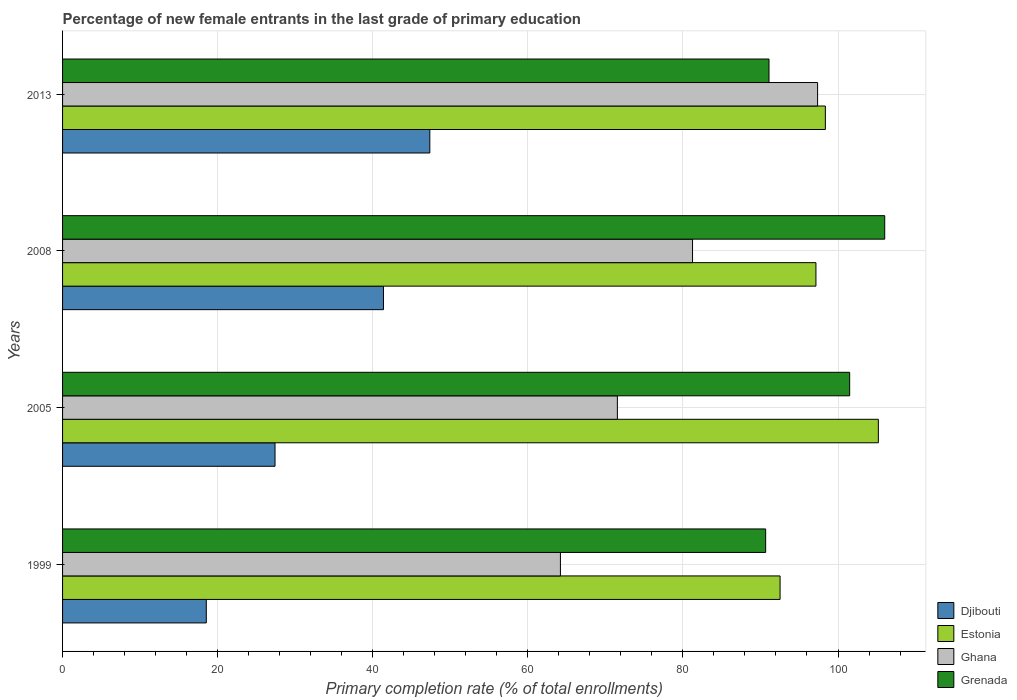What is the label of the 4th group of bars from the top?
Your answer should be very brief. 1999. What is the percentage of new female entrants in Ghana in 2013?
Provide a succinct answer. 97.37. Across all years, what is the maximum percentage of new female entrants in Estonia?
Give a very brief answer. 105.2. Across all years, what is the minimum percentage of new female entrants in Ghana?
Your response must be concise. 64.2. In which year was the percentage of new female entrants in Ghana maximum?
Ensure brevity in your answer.  2013. What is the total percentage of new female entrants in Grenada in the graph?
Your answer should be very brief. 389.3. What is the difference between the percentage of new female entrants in Djibouti in 1999 and that in 2005?
Your response must be concise. -8.86. What is the difference between the percentage of new female entrants in Grenada in 2005 and the percentage of new female entrants in Djibouti in 1999?
Provide a succinct answer. 82.97. What is the average percentage of new female entrants in Djibouti per year?
Your answer should be compact. 33.67. In the year 2008, what is the difference between the percentage of new female entrants in Ghana and percentage of new female entrants in Grenada?
Keep it short and to the point. -24.78. What is the ratio of the percentage of new female entrants in Grenada in 1999 to that in 2013?
Provide a short and direct response. 1. Is the difference between the percentage of new female entrants in Ghana in 1999 and 2013 greater than the difference between the percentage of new female entrants in Grenada in 1999 and 2013?
Your answer should be very brief. No. What is the difference between the highest and the second highest percentage of new female entrants in Grenada?
Your response must be concise. 4.52. What is the difference between the highest and the lowest percentage of new female entrants in Djibouti?
Offer a very short reply. 28.83. In how many years, is the percentage of new female entrants in Ghana greater than the average percentage of new female entrants in Ghana taken over all years?
Your answer should be very brief. 2. What does the 4th bar from the top in 2008 represents?
Provide a succinct answer. Djibouti. Is it the case that in every year, the sum of the percentage of new female entrants in Estonia and percentage of new female entrants in Ghana is greater than the percentage of new female entrants in Djibouti?
Make the answer very short. Yes. What is the difference between two consecutive major ticks on the X-axis?
Provide a short and direct response. 20. Are the values on the major ticks of X-axis written in scientific E-notation?
Keep it short and to the point. No. Where does the legend appear in the graph?
Offer a very short reply. Bottom right. How many legend labels are there?
Give a very brief answer. 4. How are the legend labels stacked?
Provide a succinct answer. Vertical. What is the title of the graph?
Give a very brief answer. Percentage of new female entrants in the last grade of primary education. What is the label or title of the X-axis?
Provide a short and direct response. Primary completion rate (% of total enrollments). What is the Primary completion rate (% of total enrollments) in Djibouti in 1999?
Offer a terse response. 18.54. What is the Primary completion rate (% of total enrollments) of Estonia in 1999?
Provide a short and direct response. 92.53. What is the Primary completion rate (% of total enrollments) of Ghana in 1999?
Give a very brief answer. 64.2. What is the Primary completion rate (% of total enrollments) of Grenada in 1999?
Give a very brief answer. 90.67. What is the Primary completion rate (% of total enrollments) in Djibouti in 2005?
Your response must be concise. 27.4. What is the Primary completion rate (% of total enrollments) in Estonia in 2005?
Offer a very short reply. 105.2. What is the Primary completion rate (% of total enrollments) of Ghana in 2005?
Provide a short and direct response. 71.55. What is the Primary completion rate (% of total enrollments) in Grenada in 2005?
Ensure brevity in your answer.  101.5. What is the Primary completion rate (% of total enrollments) in Djibouti in 2008?
Offer a very short reply. 41.38. What is the Primary completion rate (% of total enrollments) of Estonia in 2008?
Provide a succinct answer. 97.15. What is the Primary completion rate (% of total enrollments) in Ghana in 2008?
Your response must be concise. 81.24. What is the Primary completion rate (% of total enrollments) in Grenada in 2008?
Your answer should be compact. 106.02. What is the Primary completion rate (% of total enrollments) in Djibouti in 2013?
Provide a succinct answer. 47.36. What is the Primary completion rate (% of total enrollments) in Estonia in 2013?
Provide a succinct answer. 98.37. What is the Primary completion rate (% of total enrollments) of Ghana in 2013?
Your response must be concise. 97.37. What is the Primary completion rate (% of total enrollments) of Grenada in 2013?
Make the answer very short. 91.1. Across all years, what is the maximum Primary completion rate (% of total enrollments) in Djibouti?
Your answer should be compact. 47.36. Across all years, what is the maximum Primary completion rate (% of total enrollments) of Estonia?
Keep it short and to the point. 105.2. Across all years, what is the maximum Primary completion rate (% of total enrollments) in Ghana?
Ensure brevity in your answer.  97.37. Across all years, what is the maximum Primary completion rate (% of total enrollments) of Grenada?
Give a very brief answer. 106.02. Across all years, what is the minimum Primary completion rate (% of total enrollments) of Djibouti?
Your response must be concise. 18.54. Across all years, what is the minimum Primary completion rate (% of total enrollments) in Estonia?
Provide a succinct answer. 92.53. Across all years, what is the minimum Primary completion rate (% of total enrollments) of Ghana?
Keep it short and to the point. 64.2. Across all years, what is the minimum Primary completion rate (% of total enrollments) in Grenada?
Your response must be concise. 90.67. What is the total Primary completion rate (% of total enrollments) of Djibouti in the graph?
Ensure brevity in your answer.  134.68. What is the total Primary completion rate (% of total enrollments) in Estonia in the graph?
Give a very brief answer. 393.25. What is the total Primary completion rate (% of total enrollments) of Ghana in the graph?
Offer a very short reply. 314.36. What is the total Primary completion rate (% of total enrollments) in Grenada in the graph?
Make the answer very short. 389.3. What is the difference between the Primary completion rate (% of total enrollments) in Djibouti in 1999 and that in 2005?
Give a very brief answer. -8.86. What is the difference between the Primary completion rate (% of total enrollments) of Estonia in 1999 and that in 2005?
Offer a very short reply. -12.67. What is the difference between the Primary completion rate (% of total enrollments) in Ghana in 1999 and that in 2005?
Ensure brevity in your answer.  -7.34. What is the difference between the Primary completion rate (% of total enrollments) of Grenada in 1999 and that in 2005?
Your answer should be very brief. -10.83. What is the difference between the Primary completion rate (% of total enrollments) of Djibouti in 1999 and that in 2008?
Your answer should be compact. -22.85. What is the difference between the Primary completion rate (% of total enrollments) of Estonia in 1999 and that in 2008?
Make the answer very short. -4.62. What is the difference between the Primary completion rate (% of total enrollments) of Ghana in 1999 and that in 2008?
Keep it short and to the point. -17.04. What is the difference between the Primary completion rate (% of total enrollments) in Grenada in 1999 and that in 2008?
Make the answer very short. -15.35. What is the difference between the Primary completion rate (% of total enrollments) in Djibouti in 1999 and that in 2013?
Provide a short and direct response. -28.83. What is the difference between the Primary completion rate (% of total enrollments) of Estonia in 1999 and that in 2013?
Offer a very short reply. -5.84. What is the difference between the Primary completion rate (% of total enrollments) in Ghana in 1999 and that in 2013?
Give a very brief answer. -33.16. What is the difference between the Primary completion rate (% of total enrollments) of Grenada in 1999 and that in 2013?
Make the answer very short. -0.43. What is the difference between the Primary completion rate (% of total enrollments) of Djibouti in 2005 and that in 2008?
Provide a short and direct response. -13.99. What is the difference between the Primary completion rate (% of total enrollments) in Estonia in 2005 and that in 2008?
Your answer should be compact. 8.05. What is the difference between the Primary completion rate (% of total enrollments) in Ghana in 2005 and that in 2008?
Offer a very short reply. -9.69. What is the difference between the Primary completion rate (% of total enrollments) of Grenada in 2005 and that in 2008?
Provide a short and direct response. -4.52. What is the difference between the Primary completion rate (% of total enrollments) in Djibouti in 2005 and that in 2013?
Offer a terse response. -19.96. What is the difference between the Primary completion rate (% of total enrollments) of Estonia in 2005 and that in 2013?
Give a very brief answer. 6.83. What is the difference between the Primary completion rate (% of total enrollments) of Ghana in 2005 and that in 2013?
Provide a short and direct response. -25.82. What is the difference between the Primary completion rate (% of total enrollments) in Grenada in 2005 and that in 2013?
Provide a short and direct response. 10.4. What is the difference between the Primary completion rate (% of total enrollments) of Djibouti in 2008 and that in 2013?
Provide a short and direct response. -5.98. What is the difference between the Primary completion rate (% of total enrollments) of Estonia in 2008 and that in 2013?
Provide a succinct answer. -1.22. What is the difference between the Primary completion rate (% of total enrollments) in Ghana in 2008 and that in 2013?
Ensure brevity in your answer.  -16.13. What is the difference between the Primary completion rate (% of total enrollments) of Grenada in 2008 and that in 2013?
Provide a succinct answer. 14.92. What is the difference between the Primary completion rate (% of total enrollments) in Djibouti in 1999 and the Primary completion rate (% of total enrollments) in Estonia in 2005?
Your answer should be compact. -86.67. What is the difference between the Primary completion rate (% of total enrollments) in Djibouti in 1999 and the Primary completion rate (% of total enrollments) in Ghana in 2005?
Offer a very short reply. -53.01. What is the difference between the Primary completion rate (% of total enrollments) of Djibouti in 1999 and the Primary completion rate (% of total enrollments) of Grenada in 2005?
Keep it short and to the point. -82.97. What is the difference between the Primary completion rate (% of total enrollments) of Estonia in 1999 and the Primary completion rate (% of total enrollments) of Ghana in 2005?
Give a very brief answer. 20.98. What is the difference between the Primary completion rate (% of total enrollments) of Estonia in 1999 and the Primary completion rate (% of total enrollments) of Grenada in 2005?
Your answer should be compact. -8.97. What is the difference between the Primary completion rate (% of total enrollments) of Ghana in 1999 and the Primary completion rate (% of total enrollments) of Grenada in 2005?
Make the answer very short. -37.3. What is the difference between the Primary completion rate (% of total enrollments) of Djibouti in 1999 and the Primary completion rate (% of total enrollments) of Estonia in 2008?
Keep it short and to the point. -78.62. What is the difference between the Primary completion rate (% of total enrollments) in Djibouti in 1999 and the Primary completion rate (% of total enrollments) in Ghana in 2008?
Ensure brevity in your answer.  -62.7. What is the difference between the Primary completion rate (% of total enrollments) in Djibouti in 1999 and the Primary completion rate (% of total enrollments) in Grenada in 2008?
Your answer should be very brief. -87.49. What is the difference between the Primary completion rate (% of total enrollments) in Estonia in 1999 and the Primary completion rate (% of total enrollments) in Ghana in 2008?
Give a very brief answer. 11.29. What is the difference between the Primary completion rate (% of total enrollments) in Estonia in 1999 and the Primary completion rate (% of total enrollments) in Grenada in 2008?
Offer a terse response. -13.49. What is the difference between the Primary completion rate (% of total enrollments) in Ghana in 1999 and the Primary completion rate (% of total enrollments) in Grenada in 2008?
Your response must be concise. -41.82. What is the difference between the Primary completion rate (% of total enrollments) of Djibouti in 1999 and the Primary completion rate (% of total enrollments) of Estonia in 2013?
Provide a short and direct response. -79.83. What is the difference between the Primary completion rate (% of total enrollments) in Djibouti in 1999 and the Primary completion rate (% of total enrollments) in Ghana in 2013?
Provide a short and direct response. -78.83. What is the difference between the Primary completion rate (% of total enrollments) of Djibouti in 1999 and the Primary completion rate (% of total enrollments) of Grenada in 2013?
Give a very brief answer. -72.57. What is the difference between the Primary completion rate (% of total enrollments) in Estonia in 1999 and the Primary completion rate (% of total enrollments) in Ghana in 2013?
Provide a short and direct response. -4.84. What is the difference between the Primary completion rate (% of total enrollments) of Estonia in 1999 and the Primary completion rate (% of total enrollments) of Grenada in 2013?
Offer a very short reply. 1.43. What is the difference between the Primary completion rate (% of total enrollments) in Ghana in 1999 and the Primary completion rate (% of total enrollments) in Grenada in 2013?
Provide a succinct answer. -26.9. What is the difference between the Primary completion rate (% of total enrollments) in Djibouti in 2005 and the Primary completion rate (% of total enrollments) in Estonia in 2008?
Offer a terse response. -69.76. What is the difference between the Primary completion rate (% of total enrollments) in Djibouti in 2005 and the Primary completion rate (% of total enrollments) in Ghana in 2008?
Make the answer very short. -53.84. What is the difference between the Primary completion rate (% of total enrollments) in Djibouti in 2005 and the Primary completion rate (% of total enrollments) in Grenada in 2008?
Provide a succinct answer. -78.62. What is the difference between the Primary completion rate (% of total enrollments) in Estonia in 2005 and the Primary completion rate (% of total enrollments) in Ghana in 2008?
Keep it short and to the point. 23.96. What is the difference between the Primary completion rate (% of total enrollments) of Estonia in 2005 and the Primary completion rate (% of total enrollments) of Grenada in 2008?
Your answer should be very brief. -0.82. What is the difference between the Primary completion rate (% of total enrollments) of Ghana in 2005 and the Primary completion rate (% of total enrollments) of Grenada in 2008?
Keep it short and to the point. -34.48. What is the difference between the Primary completion rate (% of total enrollments) of Djibouti in 2005 and the Primary completion rate (% of total enrollments) of Estonia in 2013?
Provide a short and direct response. -70.97. What is the difference between the Primary completion rate (% of total enrollments) in Djibouti in 2005 and the Primary completion rate (% of total enrollments) in Ghana in 2013?
Your answer should be compact. -69.97. What is the difference between the Primary completion rate (% of total enrollments) in Djibouti in 2005 and the Primary completion rate (% of total enrollments) in Grenada in 2013?
Your answer should be very brief. -63.7. What is the difference between the Primary completion rate (% of total enrollments) of Estonia in 2005 and the Primary completion rate (% of total enrollments) of Ghana in 2013?
Your response must be concise. 7.83. What is the difference between the Primary completion rate (% of total enrollments) of Estonia in 2005 and the Primary completion rate (% of total enrollments) of Grenada in 2013?
Make the answer very short. 14.1. What is the difference between the Primary completion rate (% of total enrollments) of Ghana in 2005 and the Primary completion rate (% of total enrollments) of Grenada in 2013?
Offer a terse response. -19.55. What is the difference between the Primary completion rate (% of total enrollments) of Djibouti in 2008 and the Primary completion rate (% of total enrollments) of Estonia in 2013?
Provide a short and direct response. -56.98. What is the difference between the Primary completion rate (% of total enrollments) in Djibouti in 2008 and the Primary completion rate (% of total enrollments) in Ghana in 2013?
Ensure brevity in your answer.  -55.98. What is the difference between the Primary completion rate (% of total enrollments) in Djibouti in 2008 and the Primary completion rate (% of total enrollments) in Grenada in 2013?
Ensure brevity in your answer.  -49.72. What is the difference between the Primary completion rate (% of total enrollments) of Estonia in 2008 and the Primary completion rate (% of total enrollments) of Ghana in 2013?
Provide a succinct answer. -0.21. What is the difference between the Primary completion rate (% of total enrollments) of Estonia in 2008 and the Primary completion rate (% of total enrollments) of Grenada in 2013?
Make the answer very short. 6.05. What is the difference between the Primary completion rate (% of total enrollments) in Ghana in 2008 and the Primary completion rate (% of total enrollments) in Grenada in 2013?
Provide a succinct answer. -9.86. What is the average Primary completion rate (% of total enrollments) of Djibouti per year?
Offer a terse response. 33.67. What is the average Primary completion rate (% of total enrollments) in Estonia per year?
Ensure brevity in your answer.  98.31. What is the average Primary completion rate (% of total enrollments) in Ghana per year?
Your answer should be very brief. 78.59. What is the average Primary completion rate (% of total enrollments) of Grenada per year?
Provide a short and direct response. 97.32. In the year 1999, what is the difference between the Primary completion rate (% of total enrollments) of Djibouti and Primary completion rate (% of total enrollments) of Estonia?
Keep it short and to the point. -73.99. In the year 1999, what is the difference between the Primary completion rate (% of total enrollments) of Djibouti and Primary completion rate (% of total enrollments) of Ghana?
Give a very brief answer. -45.67. In the year 1999, what is the difference between the Primary completion rate (% of total enrollments) of Djibouti and Primary completion rate (% of total enrollments) of Grenada?
Give a very brief answer. -72.14. In the year 1999, what is the difference between the Primary completion rate (% of total enrollments) in Estonia and Primary completion rate (% of total enrollments) in Ghana?
Keep it short and to the point. 28.33. In the year 1999, what is the difference between the Primary completion rate (% of total enrollments) of Estonia and Primary completion rate (% of total enrollments) of Grenada?
Provide a short and direct response. 1.86. In the year 1999, what is the difference between the Primary completion rate (% of total enrollments) of Ghana and Primary completion rate (% of total enrollments) of Grenada?
Your response must be concise. -26.47. In the year 2005, what is the difference between the Primary completion rate (% of total enrollments) in Djibouti and Primary completion rate (% of total enrollments) in Estonia?
Offer a terse response. -77.8. In the year 2005, what is the difference between the Primary completion rate (% of total enrollments) of Djibouti and Primary completion rate (% of total enrollments) of Ghana?
Give a very brief answer. -44.15. In the year 2005, what is the difference between the Primary completion rate (% of total enrollments) in Djibouti and Primary completion rate (% of total enrollments) in Grenada?
Your response must be concise. -74.11. In the year 2005, what is the difference between the Primary completion rate (% of total enrollments) of Estonia and Primary completion rate (% of total enrollments) of Ghana?
Make the answer very short. 33.65. In the year 2005, what is the difference between the Primary completion rate (% of total enrollments) in Estonia and Primary completion rate (% of total enrollments) in Grenada?
Make the answer very short. 3.7. In the year 2005, what is the difference between the Primary completion rate (% of total enrollments) in Ghana and Primary completion rate (% of total enrollments) in Grenada?
Your answer should be compact. -29.96. In the year 2008, what is the difference between the Primary completion rate (% of total enrollments) in Djibouti and Primary completion rate (% of total enrollments) in Estonia?
Your answer should be very brief. -55.77. In the year 2008, what is the difference between the Primary completion rate (% of total enrollments) in Djibouti and Primary completion rate (% of total enrollments) in Ghana?
Your answer should be compact. -39.85. In the year 2008, what is the difference between the Primary completion rate (% of total enrollments) of Djibouti and Primary completion rate (% of total enrollments) of Grenada?
Your answer should be compact. -64.64. In the year 2008, what is the difference between the Primary completion rate (% of total enrollments) of Estonia and Primary completion rate (% of total enrollments) of Ghana?
Ensure brevity in your answer.  15.91. In the year 2008, what is the difference between the Primary completion rate (% of total enrollments) in Estonia and Primary completion rate (% of total enrollments) in Grenada?
Ensure brevity in your answer.  -8.87. In the year 2008, what is the difference between the Primary completion rate (% of total enrollments) in Ghana and Primary completion rate (% of total enrollments) in Grenada?
Keep it short and to the point. -24.78. In the year 2013, what is the difference between the Primary completion rate (% of total enrollments) of Djibouti and Primary completion rate (% of total enrollments) of Estonia?
Ensure brevity in your answer.  -51.01. In the year 2013, what is the difference between the Primary completion rate (% of total enrollments) of Djibouti and Primary completion rate (% of total enrollments) of Ghana?
Give a very brief answer. -50.01. In the year 2013, what is the difference between the Primary completion rate (% of total enrollments) in Djibouti and Primary completion rate (% of total enrollments) in Grenada?
Provide a succinct answer. -43.74. In the year 2013, what is the difference between the Primary completion rate (% of total enrollments) of Estonia and Primary completion rate (% of total enrollments) of Ghana?
Provide a succinct answer. 1. In the year 2013, what is the difference between the Primary completion rate (% of total enrollments) of Estonia and Primary completion rate (% of total enrollments) of Grenada?
Offer a terse response. 7.27. In the year 2013, what is the difference between the Primary completion rate (% of total enrollments) of Ghana and Primary completion rate (% of total enrollments) of Grenada?
Keep it short and to the point. 6.27. What is the ratio of the Primary completion rate (% of total enrollments) in Djibouti in 1999 to that in 2005?
Offer a terse response. 0.68. What is the ratio of the Primary completion rate (% of total enrollments) in Estonia in 1999 to that in 2005?
Your answer should be very brief. 0.88. What is the ratio of the Primary completion rate (% of total enrollments) of Ghana in 1999 to that in 2005?
Your response must be concise. 0.9. What is the ratio of the Primary completion rate (% of total enrollments) of Grenada in 1999 to that in 2005?
Offer a very short reply. 0.89. What is the ratio of the Primary completion rate (% of total enrollments) in Djibouti in 1999 to that in 2008?
Provide a succinct answer. 0.45. What is the ratio of the Primary completion rate (% of total enrollments) of Estonia in 1999 to that in 2008?
Provide a succinct answer. 0.95. What is the ratio of the Primary completion rate (% of total enrollments) in Ghana in 1999 to that in 2008?
Offer a very short reply. 0.79. What is the ratio of the Primary completion rate (% of total enrollments) of Grenada in 1999 to that in 2008?
Give a very brief answer. 0.86. What is the ratio of the Primary completion rate (% of total enrollments) in Djibouti in 1999 to that in 2013?
Make the answer very short. 0.39. What is the ratio of the Primary completion rate (% of total enrollments) in Estonia in 1999 to that in 2013?
Provide a short and direct response. 0.94. What is the ratio of the Primary completion rate (% of total enrollments) of Ghana in 1999 to that in 2013?
Offer a terse response. 0.66. What is the ratio of the Primary completion rate (% of total enrollments) in Grenada in 1999 to that in 2013?
Provide a succinct answer. 1. What is the ratio of the Primary completion rate (% of total enrollments) in Djibouti in 2005 to that in 2008?
Provide a short and direct response. 0.66. What is the ratio of the Primary completion rate (% of total enrollments) of Estonia in 2005 to that in 2008?
Your answer should be very brief. 1.08. What is the ratio of the Primary completion rate (% of total enrollments) of Ghana in 2005 to that in 2008?
Make the answer very short. 0.88. What is the ratio of the Primary completion rate (% of total enrollments) in Grenada in 2005 to that in 2008?
Make the answer very short. 0.96. What is the ratio of the Primary completion rate (% of total enrollments) in Djibouti in 2005 to that in 2013?
Provide a succinct answer. 0.58. What is the ratio of the Primary completion rate (% of total enrollments) of Estonia in 2005 to that in 2013?
Your answer should be very brief. 1.07. What is the ratio of the Primary completion rate (% of total enrollments) in Ghana in 2005 to that in 2013?
Make the answer very short. 0.73. What is the ratio of the Primary completion rate (% of total enrollments) of Grenada in 2005 to that in 2013?
Give a very brief answer. 1.11. What is the ratio of the Primary completion rate (% of total enrollments) in Djibouti in 2008 to that in 2013?
Ensure brevity in your answer.  0.87. What is the ratio of the Primary completion rate (% of total enrollments) in Estonia in 2008 to that in 2013?
Give a very brief answer. 0.99. What is the ratio of the Primary completion rate (% of total enrollments) in Ghana in 2008 to that in 2013?
Keep it short and to the point. 0.83. What is the ratio of the Primary completion rate (% of total enrollments) in Grenada in 2008 to that in 2013?
Make the answer very short. 1.16. What is the difference between the highest and the second highest Primary completion rate (% of total enrollments) in Djibouti?
Your answer should be very brief. 5.98. What is the difference between the highest and the second highest Primary completion rate (% of total enrollments) of Estonia?
Keep it short and to the point. 6.83. What is the difference between the highest and the second highest Primary completion rate (% of total enrollments) in Ghana?
Your response must be concise. 16.13. What is the difference between the highest and the second highest Primary completion rate (% of total enrollments) in Grenada?
Make the answer very short. 4.52. What is the difference between the highest and the lowest Primary completion rate (% of total enrollments) in Djibouti?
Offer a very short reply. 28.83. What is the difference between the highest and the lowest Primary completion rate (% of total enrollments) in Estonia?
Give a very brief answer. 12.67. What is the difference between the highest and the lowest Primary completion rate (% of total enrollments) of Ghana?
Make the answer very short. 33.16. What is the difference between the highest and the lowest Primary completion rate (% of total enrollments) of Grenada?
Make the answer very short. 15.35. 